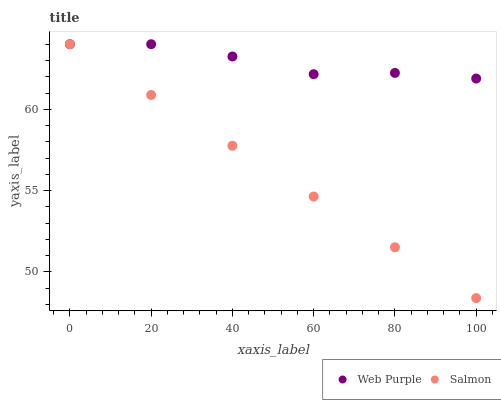Does Salmon have the minimum area under the curve?
Answer yes or no. Yes. Does Web Purple have the maximum area under the curve?
Answer yes or no. Yes. Does Salmon have the maximum area under the curve?
Answer yes or no. No. Is Salmon the smoothest?
Answer yes or no. Yes. Is Web Purple the roughest?
Answer yes or no. Yes. Is Salmon the roughest?
Answer yes or no. No. Does Salmon have the lowest value?
Answer yes or no. Yes. Does Salmon have the highest value?
Answer yes or no. Yes. Does Web Purple intersect Salmon?
Answer yes or no. Yes. Is Web Purple less than Salmon?
Answer yes or no. No. Is Web Purple greater than Salmon?
Answer yes or no. No. 